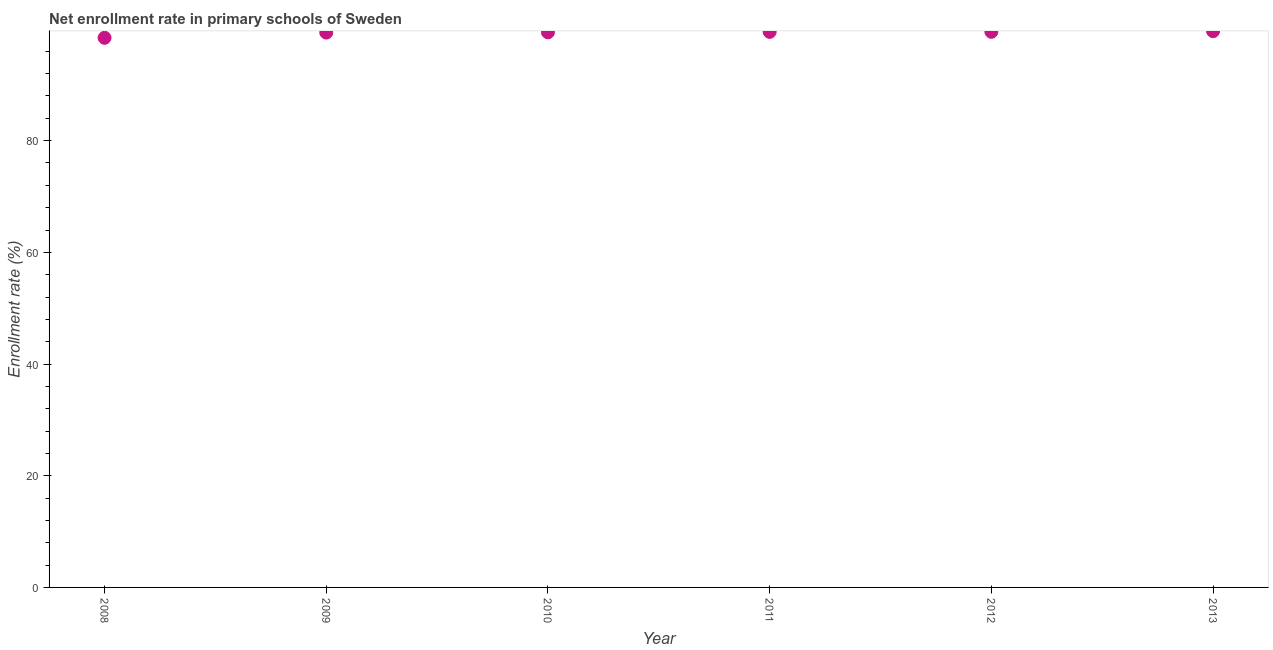What is the net enrollment rate in primary schools in 2011?
Make the answer very short. 99.47. Across all years, what is the maximum net enrollment rate in primary schools?
Give a very brief answer. 99.61. Across all years, what is the minimum net enrollment rate in primary schools?
Offer a very short reply. 98.41. What is the sum of the net enrollment rate in primary schools?
Give a very brief answer. 595.73. What is the difference between the net enrollment rate in primary schools in 2011 and 2012?
Your answer should be very brief. -0.01. What is the average net enrollment rate in primary schools per year?
Ensure brevity in your answer.  99.29. What is the median net enrollment rate in primary schools?
Make the answer very short. 99.44. What is the ratio of the net enrollment rate in primary schools in 2009 to that in 2013?
Provide a succinct answer. 1. Is the difference between the net enrollment rate in primary schools in 2008 and 2012 greater than the difference between any two years?
Offer a very short reply. No. What is the difference between the highest and the second highest net enrollment rate in primary schools?
Provide a succinct answer. 0.12. What is the difference between the highest and the lowest net enrollment rate in primary schools?
Provide a short and direct response. 1.19. In how many years, is the net enrollment rate in primary schools greater than the average net enrollment rate in primary schools taken over all years?
Give a very brief answer. 5. Does the net enrollment rate in primary schools monotonically increase over the years?
Ensure brevity in your answer.  Yes. What is the difference between two consecutive major ticks on the Y-axis?
Make the answer very short. 20. Are the values on the major ticks of Y-axis written in scientific E-notation?
Keep it short and to the point. No. What is the title of the graph?
Offer a very short reply. Net enrollment rate in primary schools of Sweden. What is the label or title of the Y-axis?
Your answer should be compact. Enrollment rate (%). What is the Enrollment rate (%) in 2008?
Make the answer very short. 98.41. What is the Enrollment rate (%) in 2009?
Offer a very short reply. 99.35. What is the Enrollment rate (%) in 2010?
Provide a short and direct response. 99.4. What is the Enrollment rate (%) in 2011?
Give a very brief answer. 99.47. What is the Enrollment rate (%) in 2012?
Your answer should be compact. 99.49. What is the Enrollment rate (%) in 2013?
Your answer should be very brief. 99.61. What is the difference between the Enrollment rate (%) in 2008 and 2009?
Your response must be concise. -0.94. What is the difference between the Enrollment rate (%) in 2008 and 2010?
Offer a very short reply. -0.98. What is the difference between the Enrollment rate (%) in 2008 and 2011?
Offer a very short reply. -1.06. What is the difference between the Enrollment rate (%) in 2008 and 2012?
Your answer should be very brief. -1.07. What is the difference between the Enrollment rate (%) in 2008 and 2013?
Your answer should be compact. -1.19. What is the difference between the Enrollment rate (%) in 2009 and 2010?
Make the answer very short. -0.05. What is the difference between the Enrollment rate (%) in 2009 and 2011?
Your answer should be compact. -0.12. What is the difference between the Enrollment rate (%) in 2009 and 2012?
Offer a very short reply. -0.14. What is the difference between the Enrollment rate (%) in 2009 and 2013?
Your answer should be compact. -0.26. What is the difference between the Enrollment rate (%) in 2010 and 2011?
Offer a very short reply. -0.08. What is the difference between the Enrollment rate (%) in 2010 and 2012?
Your answer should be compact. -0.09. What is the difference between the Enrollment rate (%) in 2010 and 2013?
Provide a short and direct response. -0.21. What is the difference between the Enrollment rate (%) in 2011 and 2012?
Give a very brief answer. -0.01. What is the difference between the Enrollment rate (%) in 2011 and 2013?
Provide a succinct answer. -0.13. What is the difference between the Enrollment rate (%) in 2012 and 2013?
Offer a very short reply. -0.12. What is the ratio of the Enrollment rate (%) in 2008 to that in 2009?
Give a very brief answer. 0.99. What is the ratio of the Enrollment rate (%) in 2008 to that in 2012?
Offer a very short reply. 0.99. What is the ratio of the Enrollment rate (%) in 2009 to that in 2010?
Provide a succinct answer. 1. What is the ratio of the Enrollment rate (%) in 2009 to that in 2011?
Provide a succinct answer. 1. What is the ratio of the Enrollment rate (%) in 2009 to that in 2013?
Offer a terse response. 1. What is the ratio of the Enrollment rate (%) in 2010 to that in 2012?
Make the answer very short. 1. What is the ratio of the Enrollment rate (%) in 2011 to that in 2012?
Provide a succinct answer. 1. What is the ratio of the Enrollment rate (%) in 2011 to that in 2013?
Your answer should be very brief. 1. What is the ratio of the Enrollment rate (%) in 2012 to that in 2013?
Keep it short and to the point. 1. 